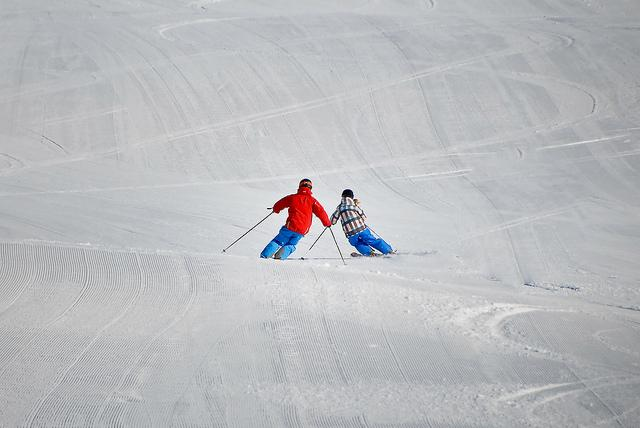What type of action are the people taking? skiing 